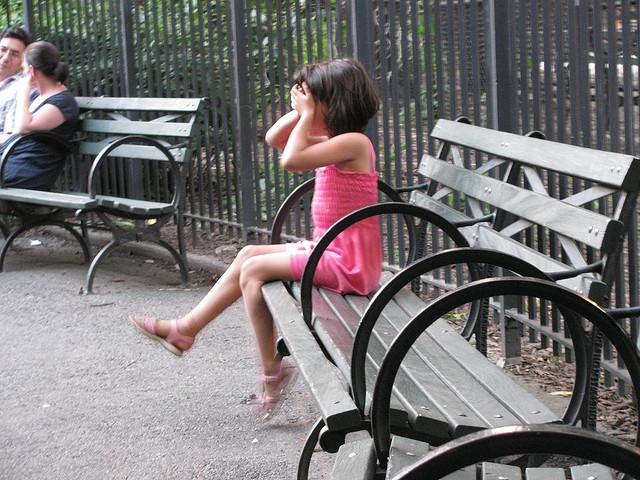What game is this girl playing?
Short answer required. Hide and seek. What color dress is the little girl wearing?
Give a very brief answer. Pink. Is the little girl moving?
Concise answer only. Yes. 